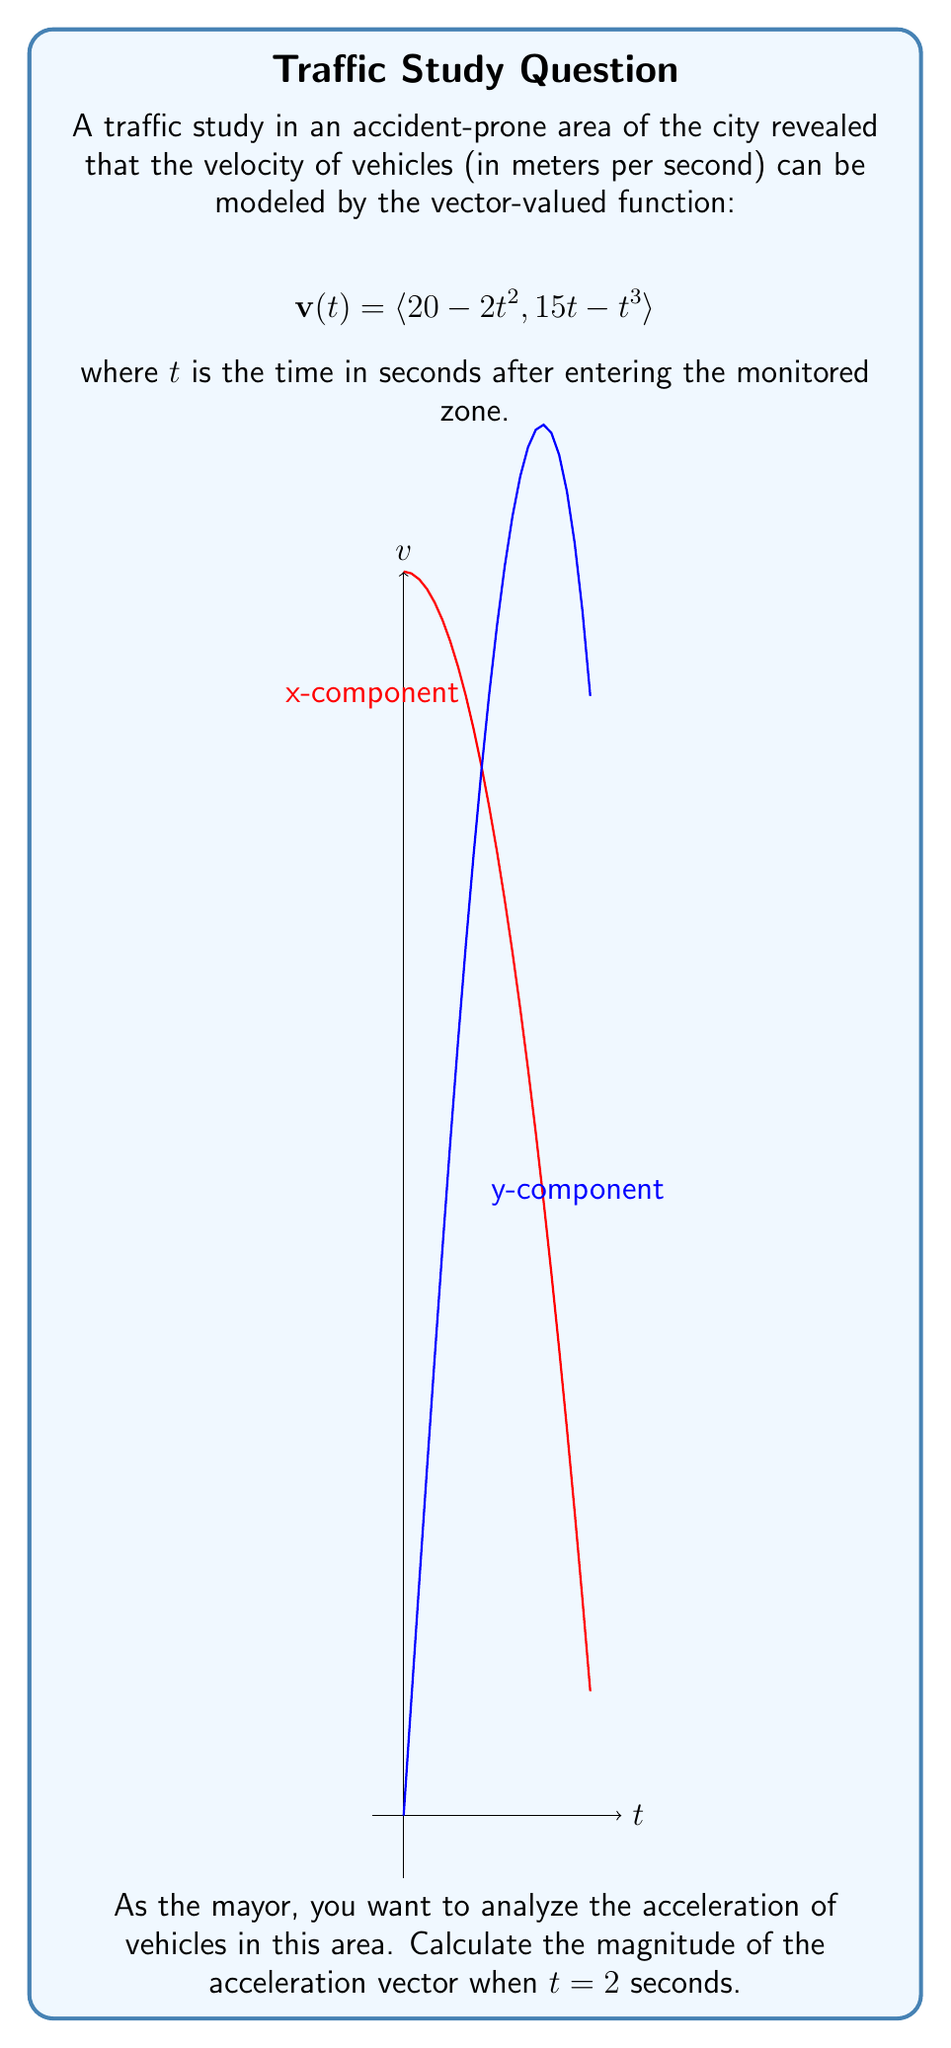Teach me how to tackle this problem. To solve this problem, we'll follow these steps:

1) First, we need to find the acceleration vector. The acceleration is the derivative of the velocity vector with respect to time.

2) Let's calculate the derivative of each component of $\mathbf{v}(t)$:

   For the x-component: $\frac{d}{dt}(20 - 2t^2) = -4t$
   For the y-component: $\frac{d}{dt}(15t - t^3) = 15 - 3t^2$

3) Therefore, the acceleration vector is:

   $$\mathbf{a}(t) = \langle -4t, 15 - 3t^2 \rangle$$

4) We need to find the magnitude of this vector when $t = 2$. Let's substitute $t = 2$ into our acceleration vector:

   $$\mathbf{a}(2) = \langle -4(2), 15 - 3(2)^2 \rangle = \langle -8, 3 \rangle$$

5) The magnitude of a vector $\langle a, b \rangle$ is given by $\sqrt{a^2 + b^2}$. So, the magnitude of our acceleration vector is:

   $$|\mathbf{a}(2)| = \sqrt{(-8)^2 + 3^2} = \sqrt{64 + 9} = \sqrt{73}$$

6) Therefore, the magnitude of the acceleration vector when $t = 2$ seconds is $\sqrt{73}$ m/s².
Answer: $\sqrt{73}$ m/s² 